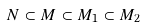<formula> <loc_0><loc_0><loc_500><loc_500>N \subset M \subset M _ { 1 } \subset M _ { 2 }</formula> 